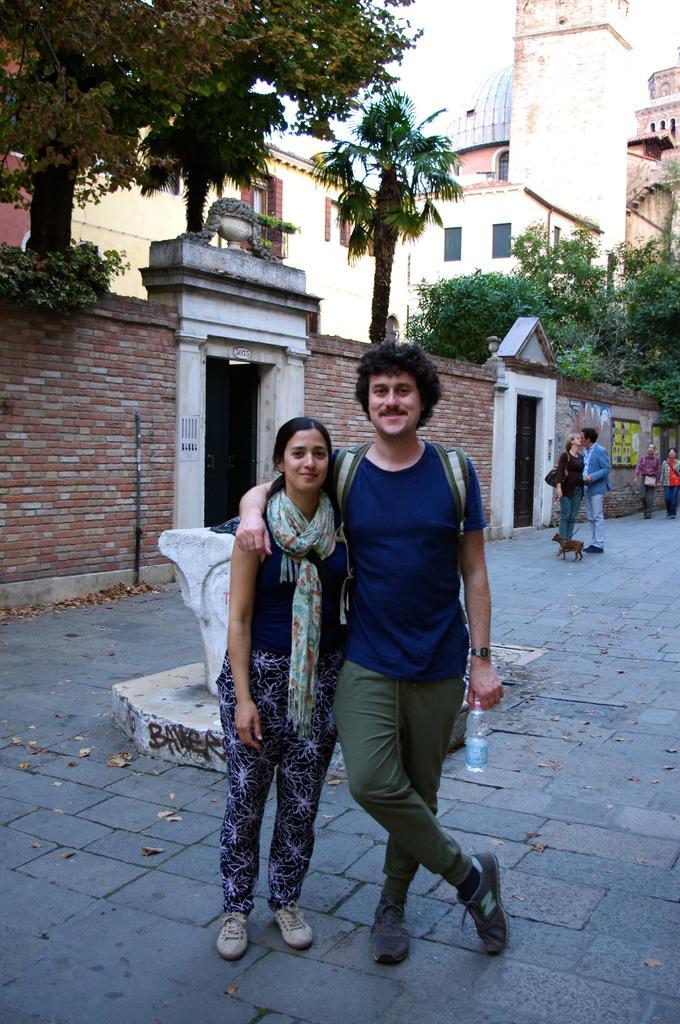Describe this image in one or two sentences. In this image, we can see people wearing clothes. There is a cement stone in front of the wall. There are some trees in front of the building. There is a dog on the right side of the image. There is a person at the bottom of the image holding a bottle with his hand. 